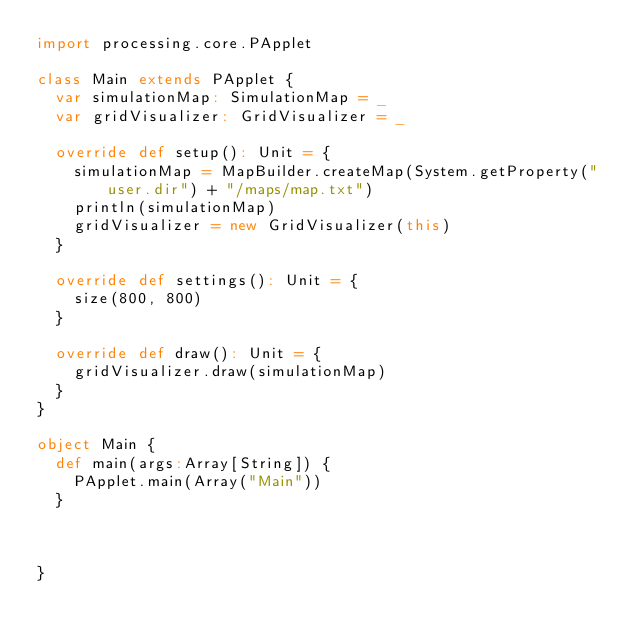<code> <loc_0><loc_0><loc_500><loc_500><_Scala_>import processing.core.PApplet

class Main extends PApplet {
  var simulationMap: SimulationMap = _
  var gridVisualizer: GridVisualizer = _

  override def setup(): Unit = {
    simulationMap = MapBuilder.createMap(System.getProperty("user.dir") + "/maps/map.txt")
    println(simulationMap)
    gridVisualizer = new GridVisualizer(this)
  }
  
  override def settings(): Unit = {
    size(800, 800)
  }

  override def draw(): Unit = {
    gridVisualizer.draw(simulationMap)
  }
}

object Main {
  def main(args:Array[String]) {
    PApplet.main(Array("Main"))
  }



}
</code> 